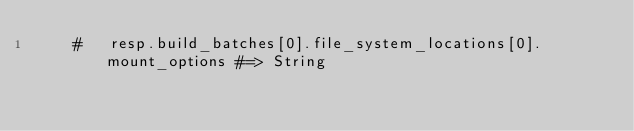<code> <loc_0><loc_0><loc_500><loc_500><_Ruby_>    #   resp.build_batches[0].file_system_locations[0].mount_options #=> String</code> 